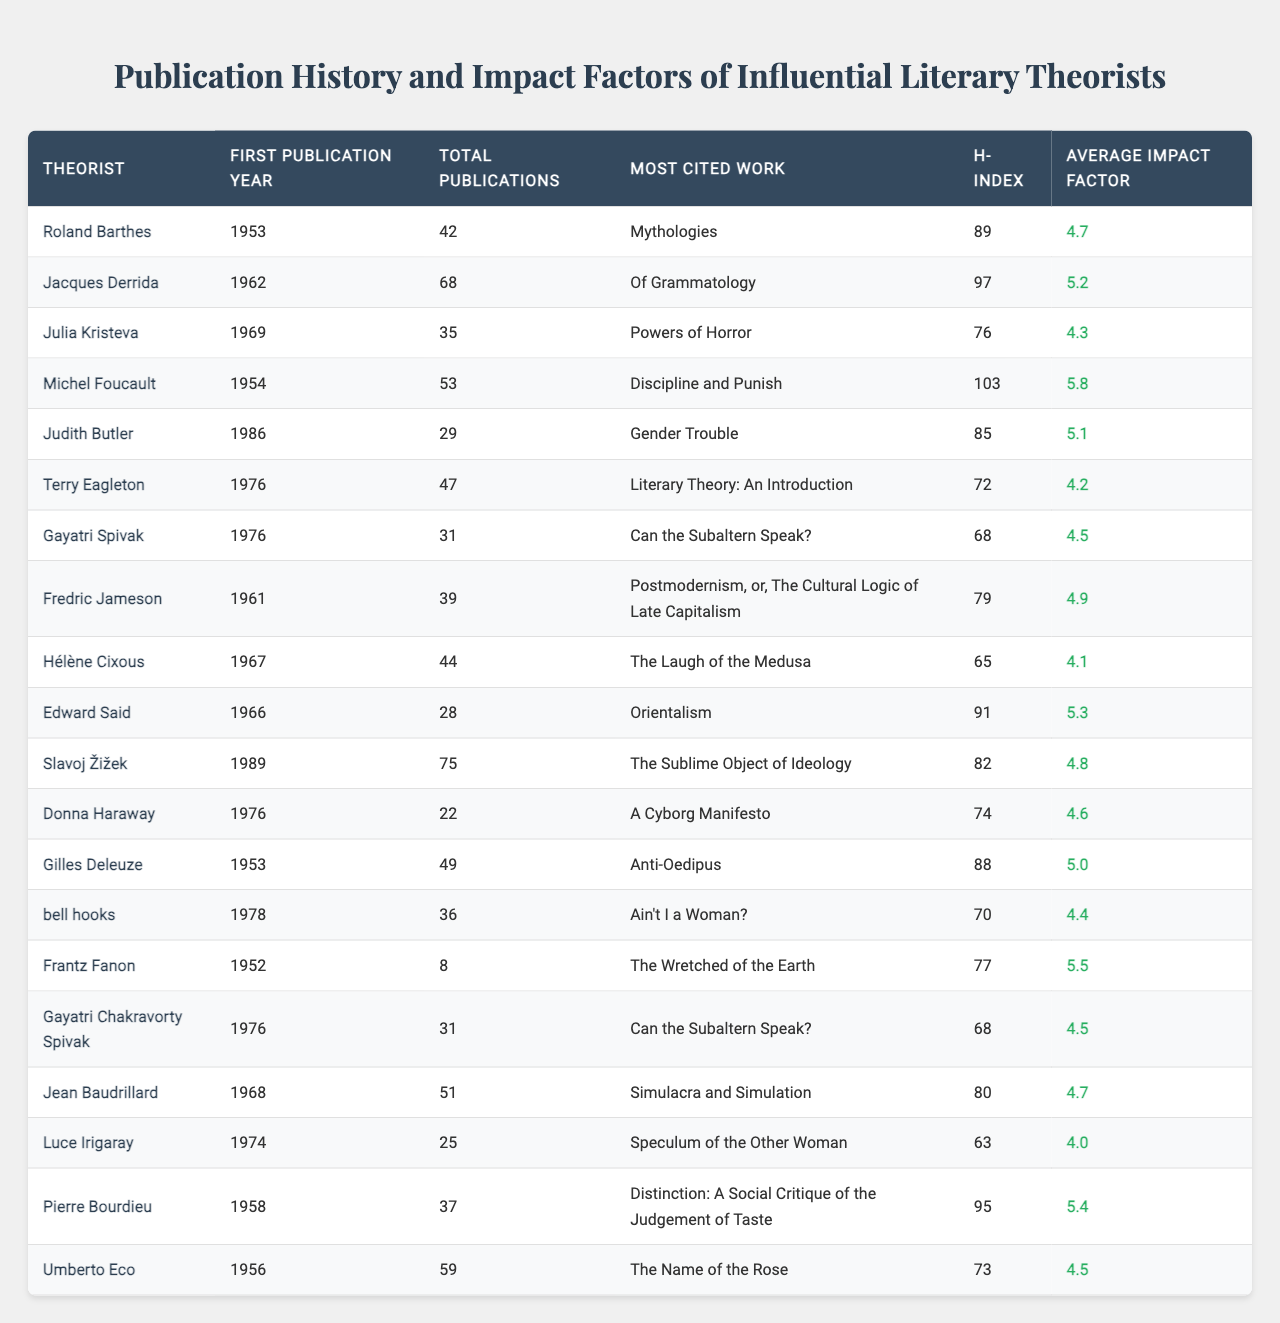What is the most cited work of Michel Foucault? According to the table, Michel Foucault's most cited work is "Discipline and Punish."
Answer: "Discipline and Punish" Which theorist has the highest h-index? The table shows that Michel Foucault has the highest h-index of 103.
Answer: Michel Foucault What is the average impact factor of Julia Kristeva's publications? Julia Kristeva's average impact factor, as listed in the table, is 4.3.
Answer: 4.3 How many total publications did Roland Barthes and Judith Butler have combined? The total publications for Roland Barthes is 42 and for Judith Butler is 29. Their combined total is 42 + 29 = 71.
Answer: 71 Is the average impact factor of Terry Eagleton higher than that of Gayatri Spivak? Terry Eagleton's average impact factor is 4.2, and Gayatri Spivak's is 4.5. Since 4.2 is less than 4.5, the statement is false.
Answer: No How many theorists had more than 50 total publications? By reviewing the data, the theorists with more than 50 publications are Jacques Derrida (68), Michel Foucault (53), Slavoj Žižek (75), and Umberto Eco (59). There are 4 theorists that meet this criterion.
Answer: 4 What is the difference in the h-index between Pierre Bourdieu and Jean Baudrillard? Pierre Bourdieu has an h-index of 95, while Jean Baudrillard's is 80. The difference is 95 - 80 = 15.
Answer: 15 Who had their first publication in the earliest year and what was that year? By examining the data, Frantz Fanon, whose first publication year is 1952, is the earliest.
Answer: 1952 What is the average impact factor of all theorists in the table? To calculate the average impact factor, sum all the average impact factors (4.7 + 5.2 + 4.3 + 5.8 + 5.1 + 4.2 + 4.5 + 4.9 + 4.1 + 5.3 + 4.8 + 4.6 + 5.0 + 4.4 + 5.5 + 4.5 + 4.7 + 4.0 + 5.4 + 4.5 = 88.1) and then divide by the number of theorists (20). The average is 88.1 / 20 = 4.405.
Answer: 4.405 Which theorist has the most publications and what is the total? According to the table, Slavoj Žižek has the most publications with a total of 75.
Answer: 75 